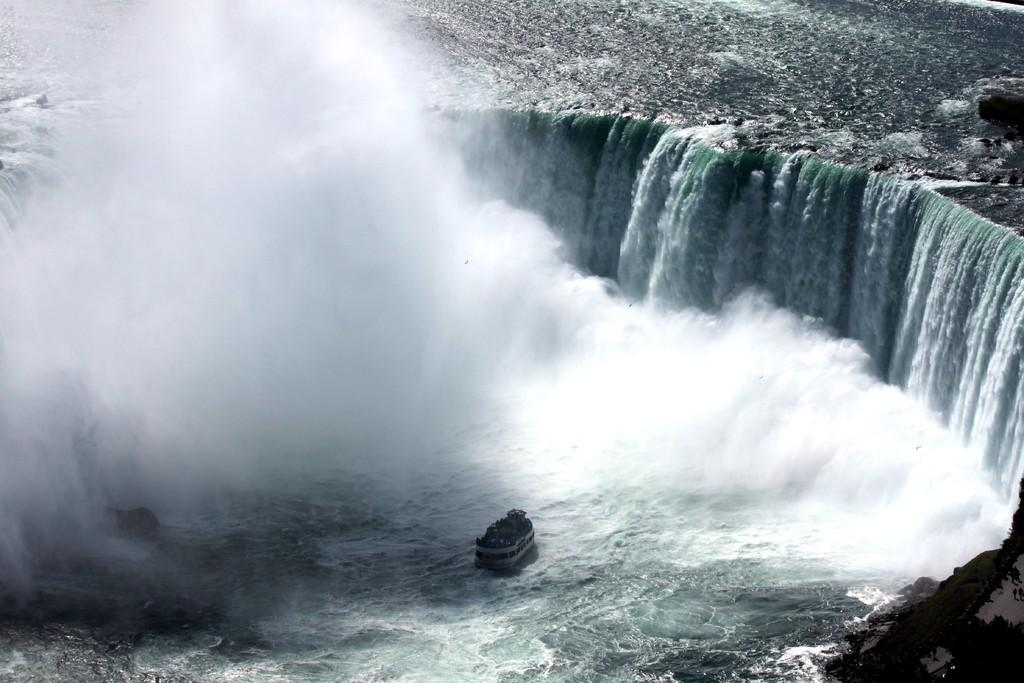What is the main subject of the image? The main subject of the image is a ship. Where is the ship located? The ship is on the water. What can be seen in the background of the image? There are waterfalls in the background of the image. What type of fruit is hanging from the ship's mast in the image? There is no fruit hanging from the ship's mast in the image. 